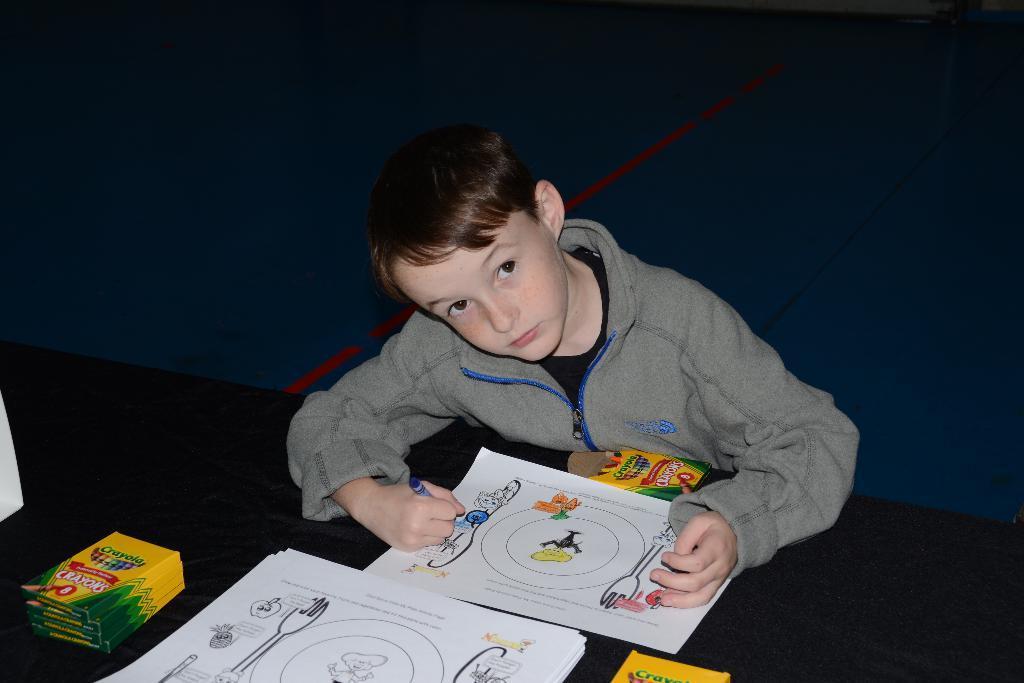Describe this image in one or two sentences. In this image, we can see a table contains papers and sketch boxes. There is a kid in the middle of the image wearing clothes and coloring a picture. 